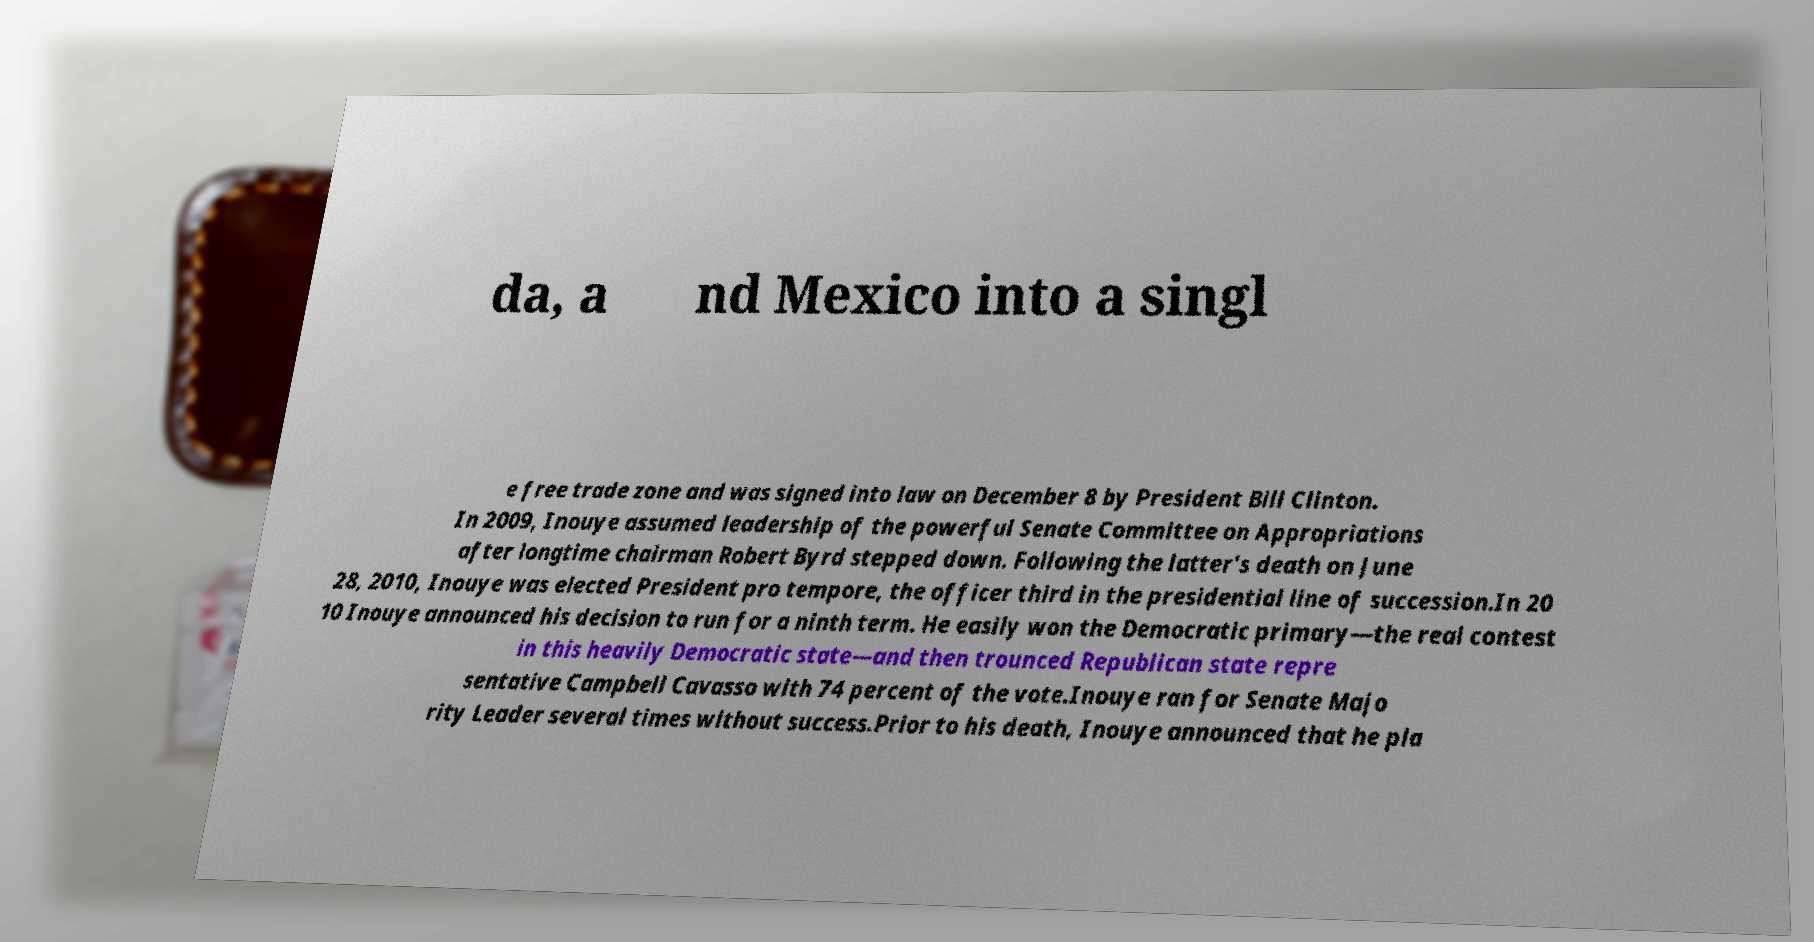There's text embedded in this image that I need extracted. Can you transcribe it verbatim? da, a nd Mexico into a singl e free trade zone and was signed into law on December 8 by President Bill Clinton. In 2009, Inouye assumed leadership of the powerful Senate Committee on Appropriations after longtime chairman Robert Byrd stepped down. Following the latter's death on June 28, 2010, Inouye was elected President pro tempore, the officer third in the presidential line of succession.In 20 10 Inouye announced his decision to run for a ninth term. He easily won the Democratic primary—the real contest in this heavily Democratic state—and then trounced Republican state repre sentative Campbell Cavasso with 74 percent of the vote.Inouye ran for Senate Majo rity Leader several times without success.Prior to his death, Inouye announced that he pla 